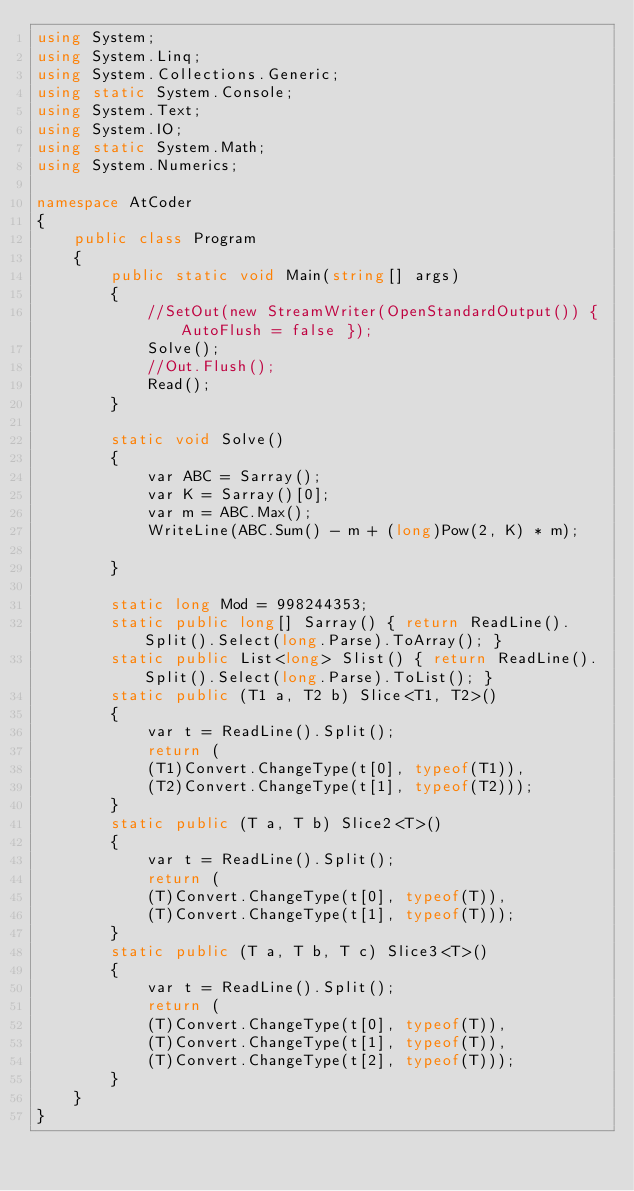<code> <loc_0><loc_0><loc_500><loc_500><_C#_>using System;
using System.Linq;
using System.Collections.Generic;
using static System.Console;
using System.Text;
using System.IO;
using static System.Math;
using System.Numerics;

namespace AtCoder
{
    public class Program
    {
        public static void Main(string[] args)
        {
            //SetOut(new StreamWriter(OpenStandardOutput()) { AutoFlush = false });
            Solve();
            //Out.Flush();
            Read();
        }

        static void Solve()
        {
            var ABC = Sarray();
            var K = Sarray()[0];
            var m = ABC.Max();
            WriteLine(ABC.Sum() - m + (long)Pow(2, K) * m);
            
        }

        static long Mod = 998244353;
        static public long[] Sarray() { return ReadLine().Split().Select(long.Parse).ToArray(); }
        static public List<long> Slist() { return ReadLine().Split().Select(long.Parse).ToList(); }
        static public (T1 a, T2 b) Slice<T1, T2>()
        {
            var t = ReadLine().Split();
            return (
            (T1)Convert.ChangeType(t[0], typeof(T1)),
            (T2)Convert.ChangeType(t[1], typeof(T2)));
        }
        static public (T a, T b) Slice2<T>()
        {
            var t = ReadLine().Split();
            return (
            (T)Convert.ChangeType(t[0], typeof(T)),
            (T)Convert.ChangeType(t[1], typeof(T)));
        }
        static public (T a, T b, T c) Slice3<T>()
        {
            var t = ReadLine().Split();
            return (
            (T)Convert.ChangeType(t[0], typeof(T)),
            (T)Convert.ChangeType(t[1], typeof(T)),
            (T)Convert.ChangeType(t[2], typeof(T)));
        }
    }
}</code> 